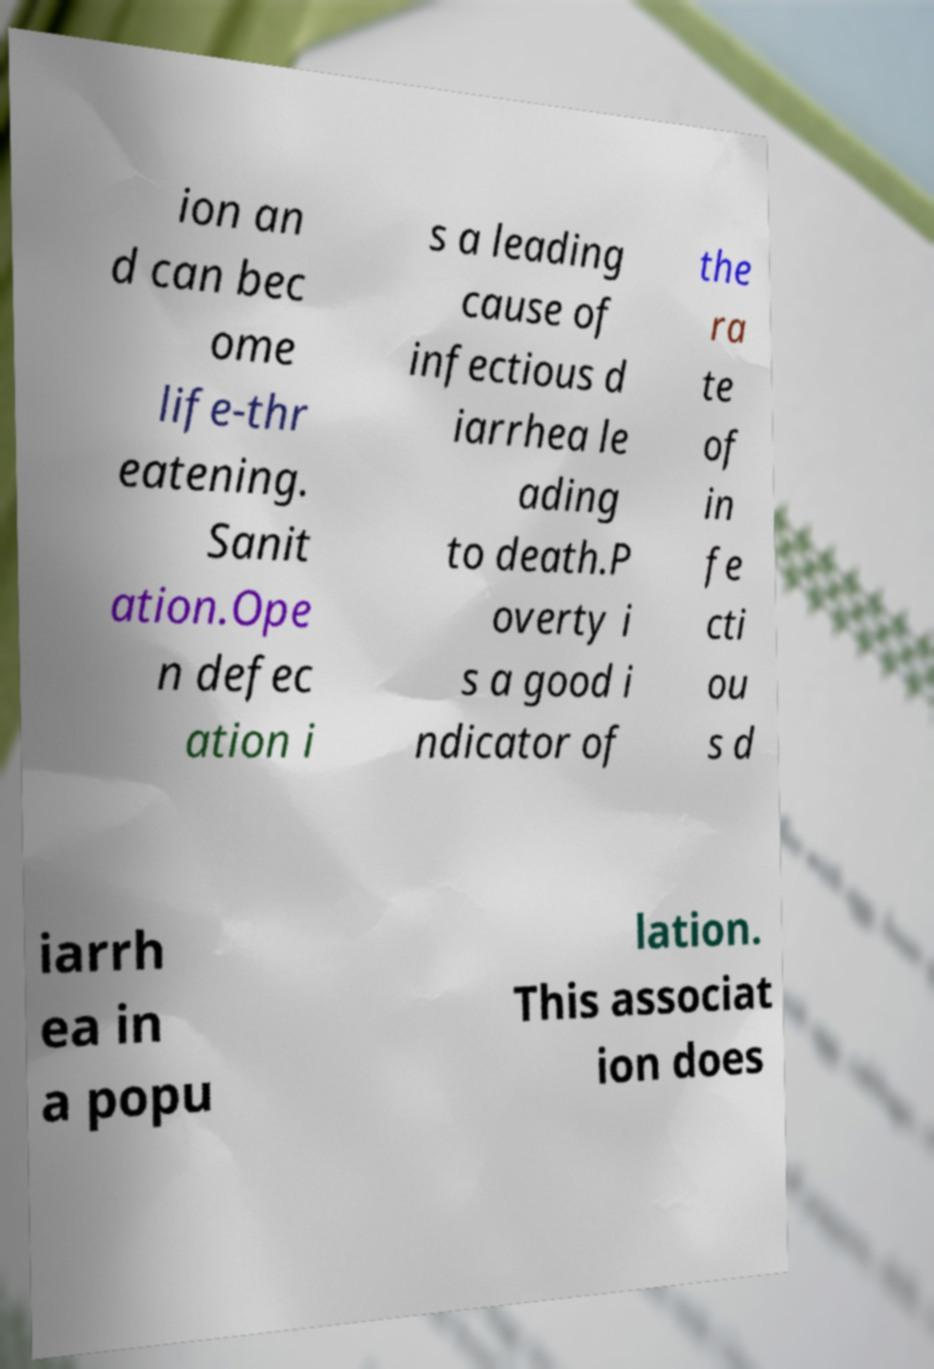For documentation purposes, I need the text within this image transcribed. Could you provide that? ion an d can bec ome life-thr eatening. Sanit ation.Ope n defec ation i s a leading cause of infectious d iarrhea le ading to death.P overty i s a good i ndicator of the ra te of in fe cti ou s d iarrh ea in a popu lation. This associat ion does 